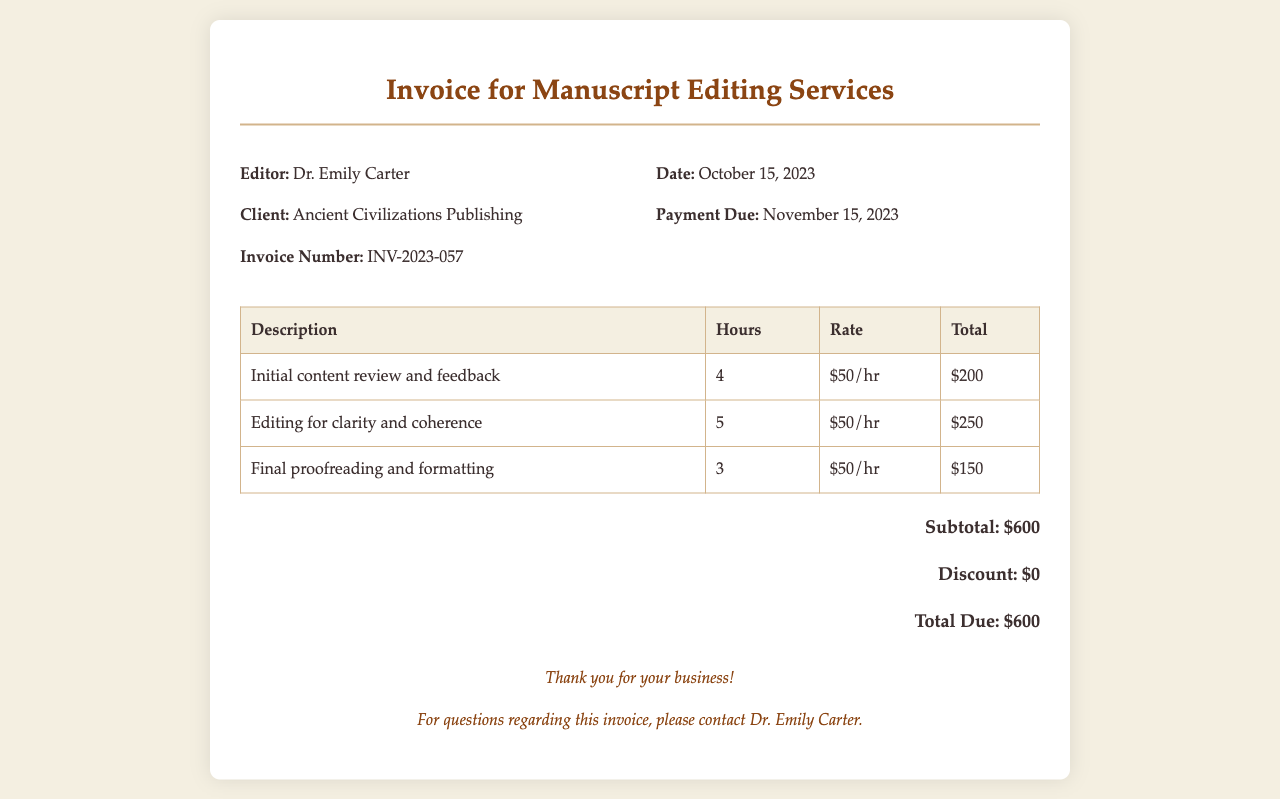What is the editor's name? The editor's name is listed under the invoice details section of the document.
Answer: Dr. Emily Carter What is the total due amount? The total due amount is stated in the total section of the document, summarizing the cost of services rendered.
Answer: $600 How many hours were spent on editing for clarity and coherence? The number of hours for editing for clarity and coherence is specified in the corresponding row of the table in the document.
Answer: 5 What is the invoice number? The invoice number can be found in the invoice details section and helps identify this specific invoice.
Answer: INV-2023-057 What is the rate charged per hour for editing services? The hourly rate is indicated within the table for each task where services were provided.
Answer: $50/hr How many hours were worked in total? The total hours can be calculated by summing all the hours listed for each task in the table.
Answer: 12 When is the payment due? The payment due date is listed in the invoice details section and indicates when the payment should be made.
Answer: November 15, 2023 What service took the longest to complete? The longest service can be determined by comparing the hours listed for each task in the table.
Answer: Editing for clarity and coherence What is the subtotal before discounts? The subtotal before any discounts is stated in the total section of the document and reflects the accumulated cost of services.
Answer: $600 